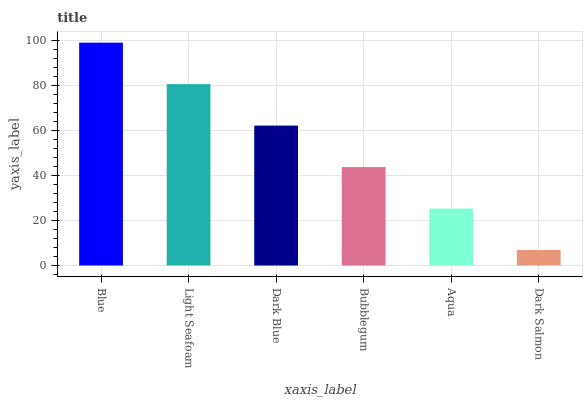Is Dark Salmon the minimum?
Answer yes or no. Yes. Is Blue the maximum?
Answer yes or no. Yes. Is Light Seafoam the minimum?
Answer yes or no. No. Is Light Seafoam the maximum?
Answer yes or no. No. Is Blue greater than Light Seafoam?
Answer yes or no. Yes. Is Light Seafoam less than Blue?
Answer yes or no. Yes. Is Light Seafoam greater than Blue?
Answer yes or no. No. Is Blue less than Light Seafoam?
Answer yes or no. No. Is Dark Blue the high median?
Answer yes or no. Yes. Is Bubblegum the low median?
Answer yes or no. Yes. Is Aqua the high median?
Answer yes or no. No. Is Dark Blue the low median?
Answer yes or no. No. 